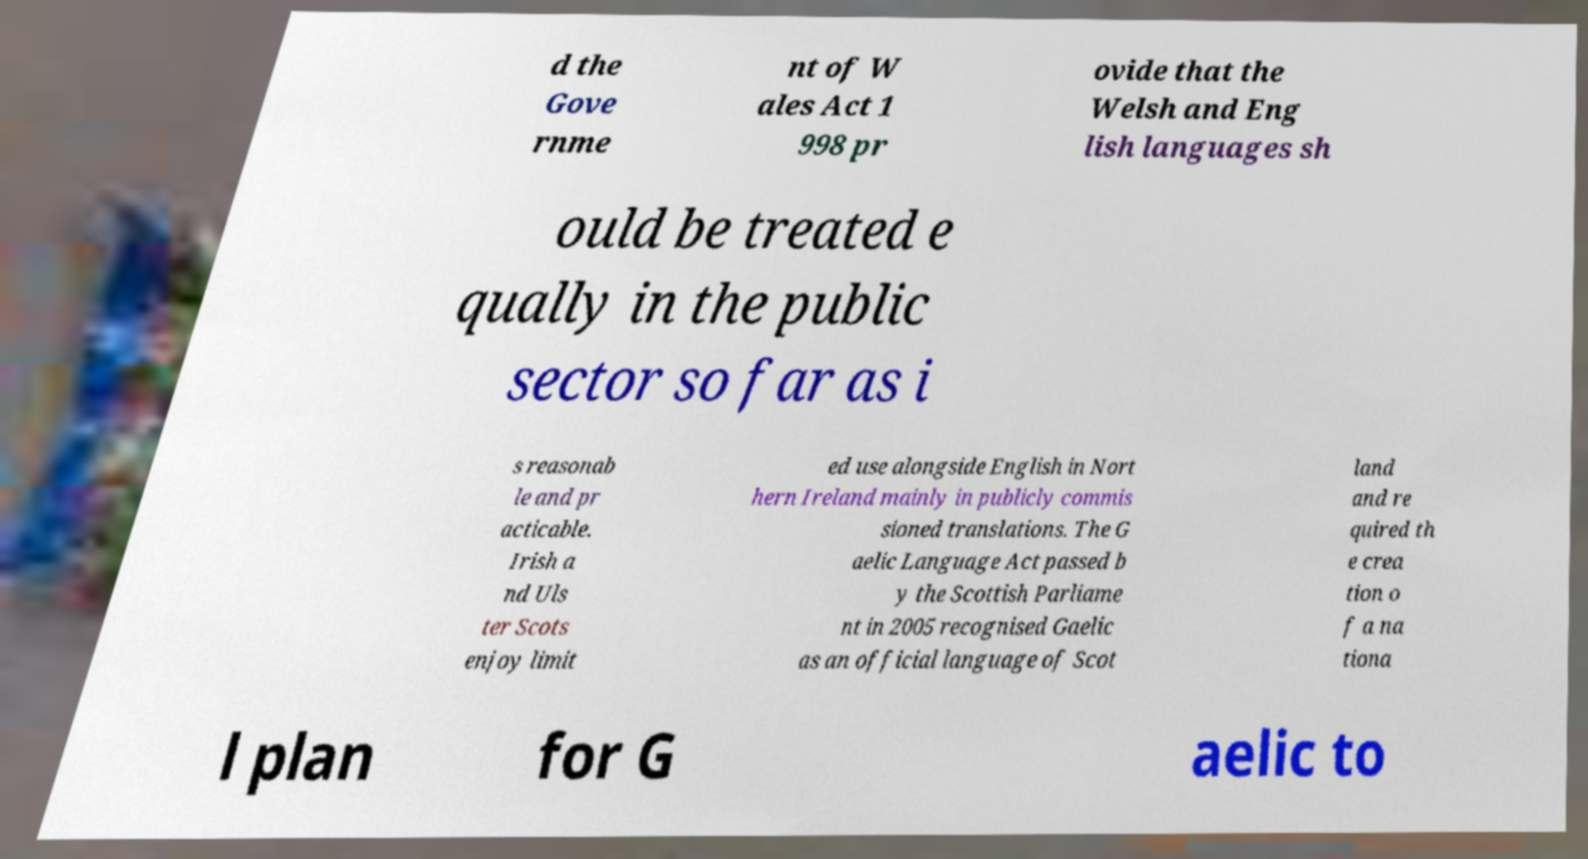What messages or text are displayed in this image? I need them in a readable, typed format. d the Gove rnme nt of W ales Act 1 998 pr ovide that the Welsh and Eng lish languages sh ould be treated e qually in the public sector so far as i s reasonab le and pr acticable. Irish a nd Uls ter Scots enjoy limit ed use alongside English in Nort hern Ireland mainly in publicly commis sioned translations. The G aelic Language Act passed b y the Scottish Parliame nt in 2005 recognised Gaelic as an official language of Scot land and re quired th e crea tion o f a na tiona l plan for G aelic to 